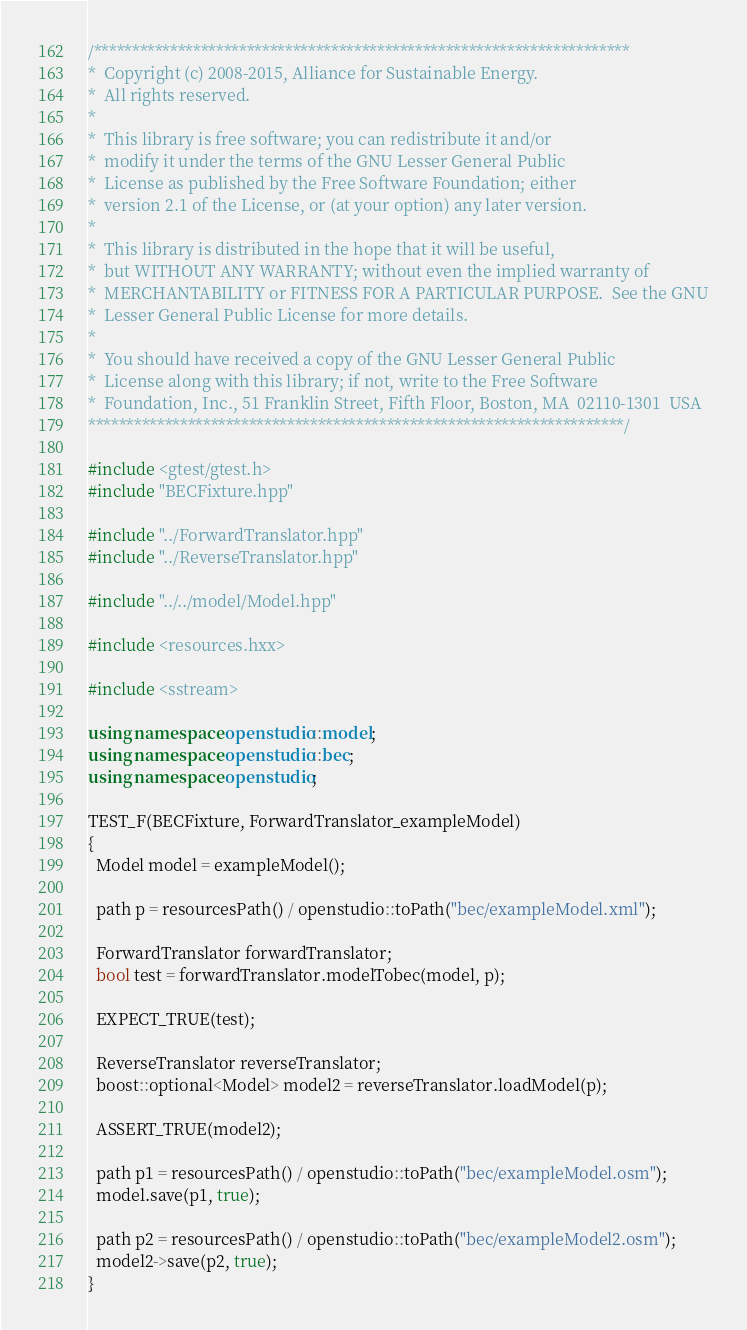<code> <loc_0><loc_0><loc_500><loc_500><_C++_>/**********************************************************************
*  Copyright (c) 2008-2015, Alliance for Sustainable Energy.
*  All rights reserved.
*
*  This library is free software; you can redistribute it and/or
*  modify it under the terms of the GNU Lesser General Public
*  License as published by the Free Software Foundation; either
*  version 2.1 of the License, or (at your option) any later version.
*
*  This library is distributed in the hope that it will be useful,
*  but WITHOUT ANY WARRANTY; without even the implied warranty of
*  MERCHANTABILITY or FITNESS FOR A PARTICULAR PURPOSE.  See the GNU
*  Lesser General Public License for more details.
*
*  You should have received a copy of the GNU Lesser General Public
*  License along with this library; if not, write to the Free Software
*  Foundation, Inc., 51 Franklin Street, Fifth Floor, Boston, MA  02110-1301  USA
**********************************************************************/

#include <gtest/gtest.h>
#include "BECFixture.hpp"

#include "../ForwardTranslator.hpp"
#include "../ReverseTranslator.hpp"

#include "../../model/Model.hpp"

#include <resources.hxx>

#include <sstream>

using namespace openstudio::model;
using namespace openstudio::bec;
using namespace openstudio;

TEST_F(BECFixture, ForwardTranslator_exampleModel)
{
  Model model = exampleModel();

  path p = resourcesPath() / openstudio::toPath("bec/exampleModel.xml");

  ForwardTranslator forwardTranslator;
  bool test = forwardTranslator.modelTobec(model, p);

  EXPECT_TRUE(test);

  ReverseTranslator reverseTranslator;
  boost::optional<Model> model2 = reverseTranslator.loadModel(p);

  ASSERT_TRUE(model2);

  path p1 = resourcesPath() / openstudio::toPath("bec/exampleModel.osm");
  model.save(p1, true);

  path p2 = resourcesPath() / openstudio::toPath("bec/exampleModel2.osm");
  model2->save(p2, true);
}
</code> 